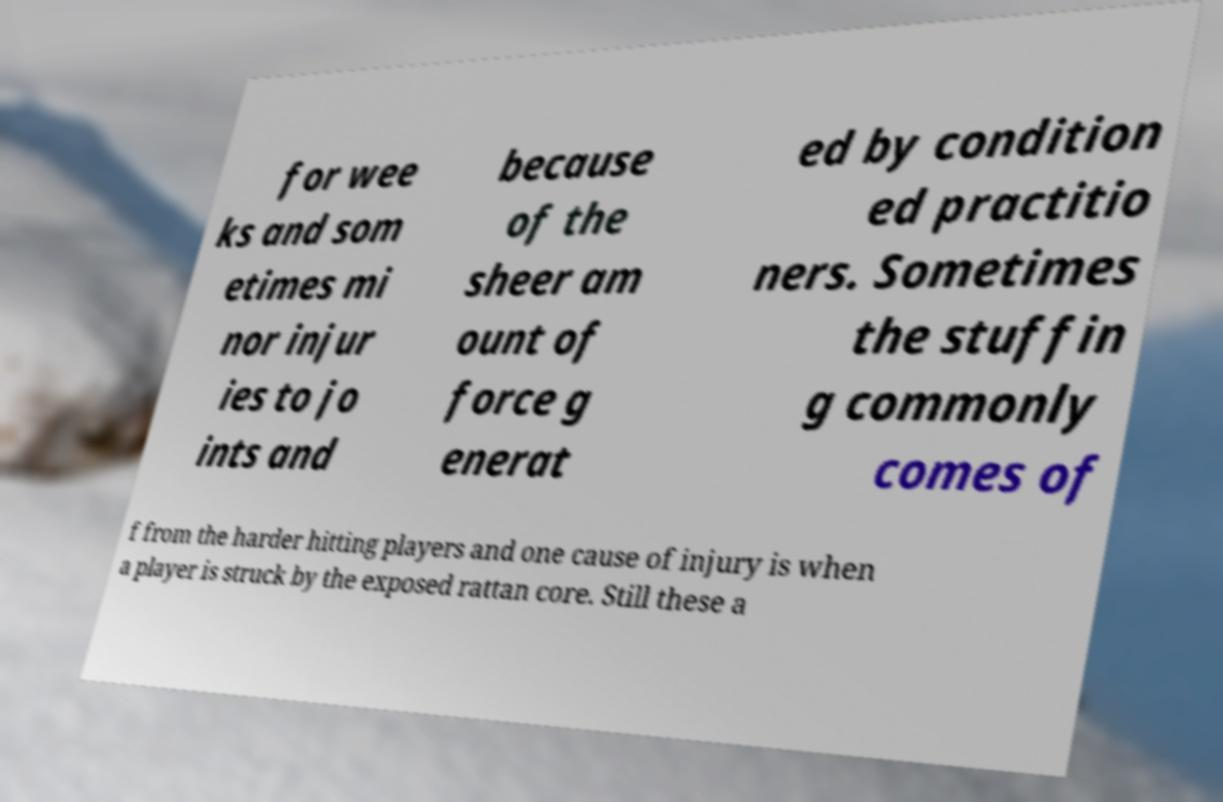Can you accurately transcribe the text from the provided image for me? for wee ks and som etimes mi nor injur ies to jo ints and because of the sheer am ount of force g enerat ed by condition ed practitio ners. Sometimes the stuffin g commonly comes of f from the harder hitting players and one cause of injury is when a player is struck by the exposed rattan core. Still these a 